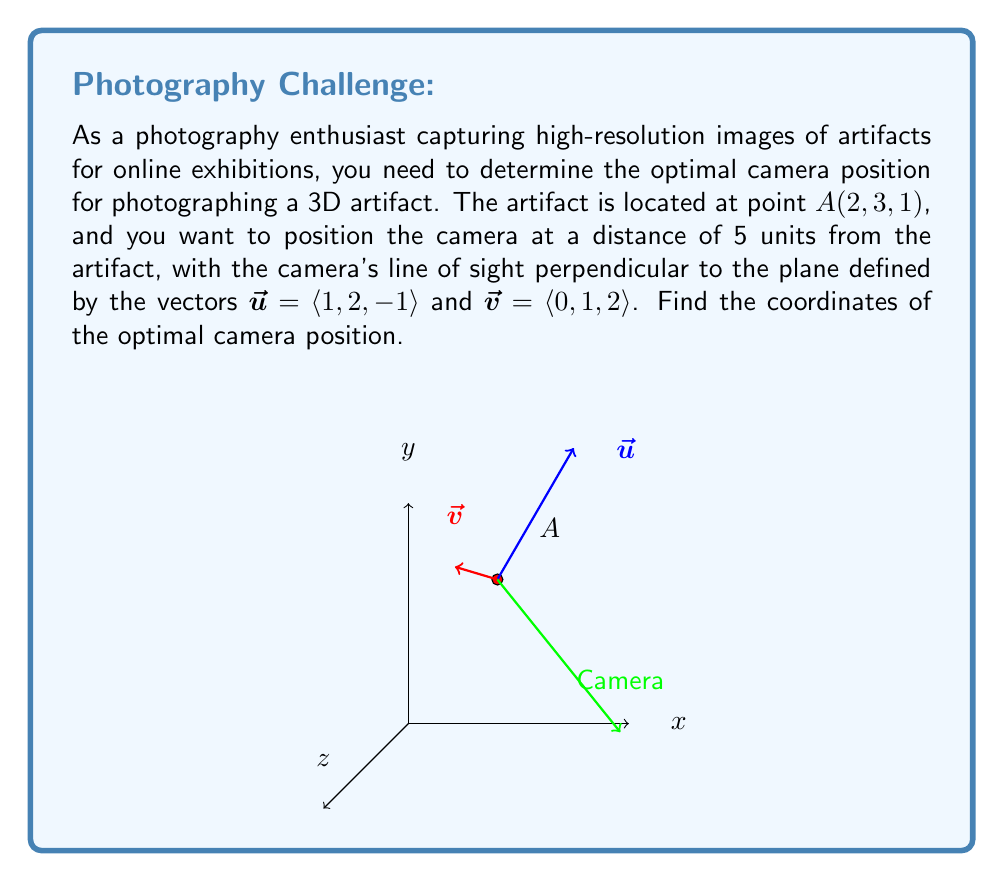Provide a solution to this math problem. Let's solve this problem step by step:

1) First, we need to find the normal vector to the plane defined by $\vec{u}$ and $\vec{v}$. We can do this using the cross product:

   $\vec{n} = \vec{u} \times \vec{v} = \langle 1, 2, -1 \rangle \times \langle 0, 1, 2 \rangle$
   
   $= \langle (2)(2) - (-1)(1), (-1)(0) - (1)(2), (1)(1) - (2)(0) \rangle$
   
   $= \langle 4 + 1, 0 - 2, 1 - 0 \rangle = \langle 5, -2, 1 \rangle$

2) We need to normalize this vector to get a unit vector in the direction of the camera's line of sight:

   $\vec{n}_{\text{unit}} = \frac{\vec{n}}{|\vec{n}|} = \frac{\langle 5, -2, 1 \rangle}{\sqrt{5^2 + (-2)^2 + 1^2}} = \frac{\langle 5, -2, 1 \rangle}{\sqrt{30}}$

3) The camera should be positioned 5 units away from the artifact in this direction. So, we can find the camera position by:

   $\text{Camera Position} = \text{Artifact Position} + 5 \cdot \vec{n}_{\text{unit}}$

   $= \langle 2, 3, 1 \rangle + 5 \cdot \frac{\langle 5, -2, 1 \rangle}{\sqrt{30}}$

   $= \langle 2, 3, 1 \rangle + \frac{\langle 25, -10, 5 \rangle}{\sqrt{30}}$

4) Simplifying:

   $= \langle 2 + \frac{25}{\sqrt{30}}, 3 - \frac{10}{\sqrt{30}}, 1 + \frac{5}{\sqrt{30}} \rangle$

This gives us the coordinates of the optimal camera position.
Answer: $\langle 2 + \frac{25}{\sqrt{30}}, 3 - \frac{10}{\sqrt{30}}, 1 + \frac{5}{\sqrt{30}} \rangle$ 